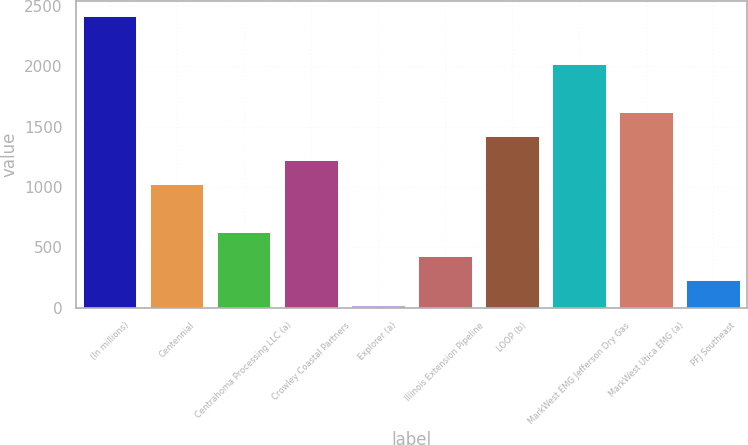Convert chart. <chart><loc_0><loc_0><loc_500><loc_500><bar_chart><fcel>(In millions)<fcel>Centennial<fcel>Centrahoma Processing LLC (a)<fcel>Crowley Coastal Partners<fcel>Explorer (a)<fcel>Illinois Extension Pipeline<fcel>LOOP (b)<fcel>MarkWest EMG Jefferson Dry Gas<fcel>MarkWest Utica EMG (a)<fcel>PFJ Southeast<nl><fcel>2415.4<fcel>1021<fcel>622.6<fcel>1220.2<fcel>25<fcel>423.4<fcel>1419.4<fcel>2017<fcel>1618.6<fcel>224.2<nl></chart> 